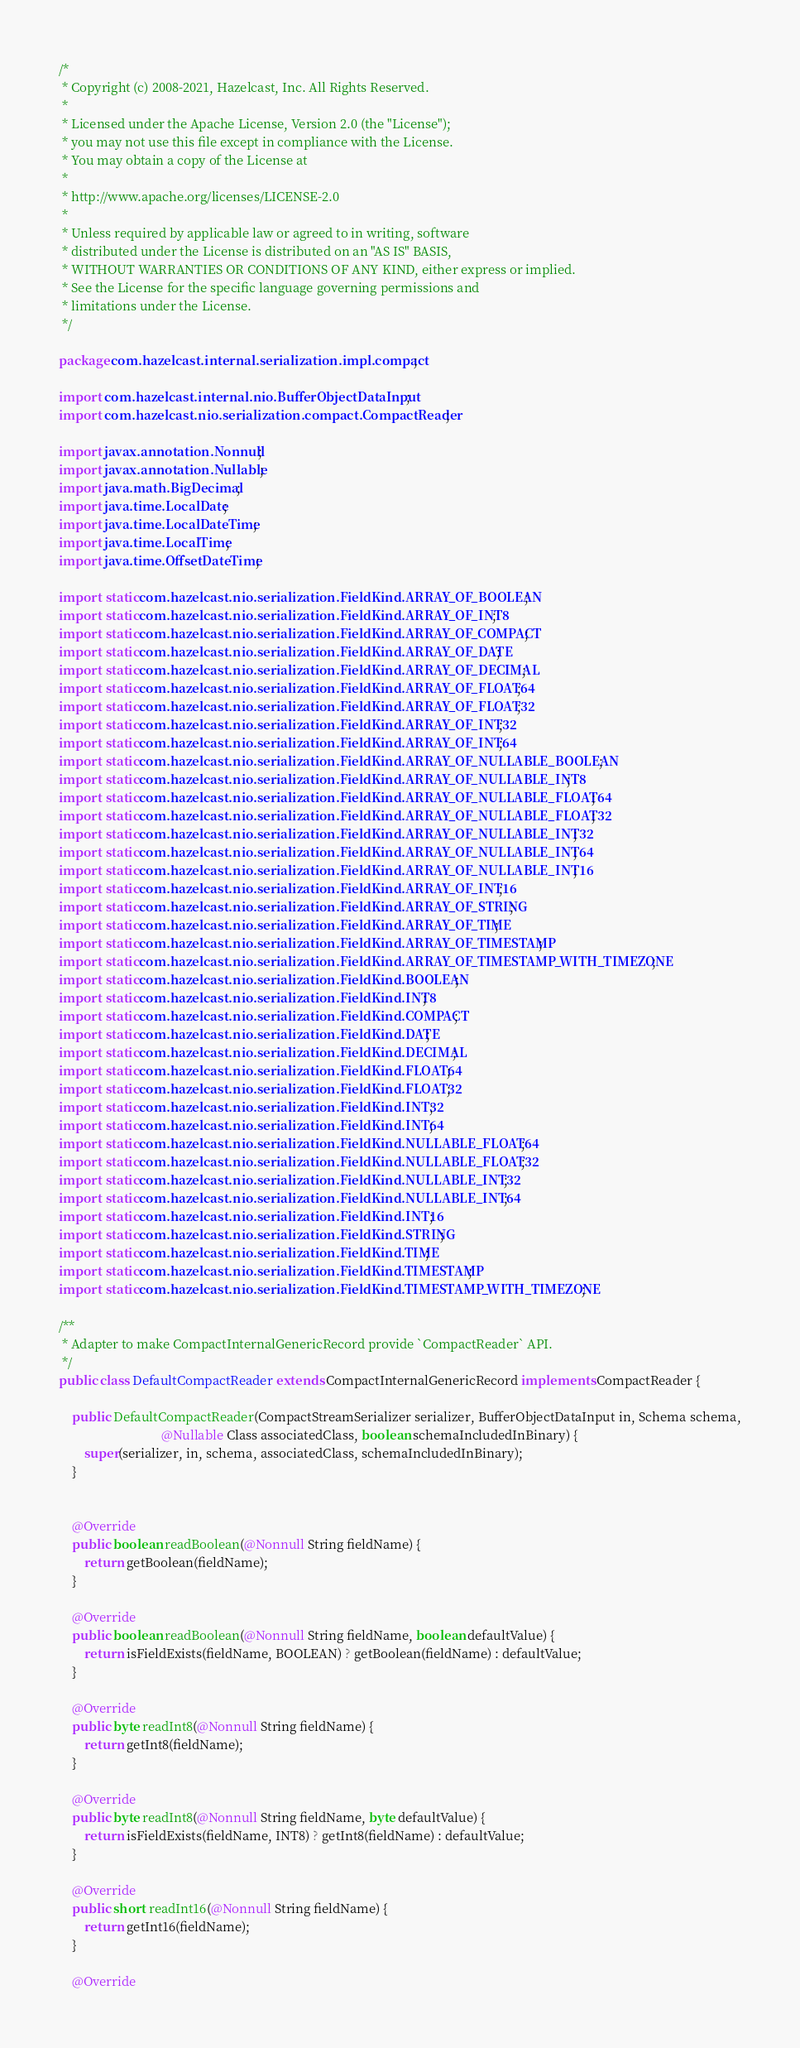<code> <loc_0><loc_0><loc_500><loc_500><_Java_>/*
 * Copyright (c) 2008-2021, Hazelcast, Inc. All Rights Reserved.
 *
 * Licensed under the Apache License, Version 2.0 (the "License");
 * you may not use this file except in compliance with the License.
 * You may obtain a copy of the License at
 *
 * http://www.apache.org/licenses/LICENSE-2.0
 *
 * Unless required by applicable law or agreed to in writing, software
 * distributed under the License is distributed on an "AS IS" BASIS,
 * WITHOUT WARRANTIES OR CONDITIONS OF ANY KIND, either express or implied.
 * See the License for the specific language governing permissions and
 * limitations under the License.
 */

package com.hazelcast.internal.serialization.impl.compact;

import com.hazelcast.internal.nio.BufferObjectDataInput;
import com.hazelcast.nio.serialization.compact.CompactReader;

import javax.annotation.Nonnull;
import javax.annotation.Nullable;
import java.math.BigDecimal;
import java.time.LocalDate;
import java.time.LocalDateTime;
import java.time.LocalTime;
import java.time.OffsetDateTime;

import static com.hazelcast.nio.serialization.FieldKind.ARRAY_OF_BOOLEAN;
import static com.hazelcast.nio.serialization.FieldKind.ARRAY_OF_INT8;
import static com.hazelcast.nio.serialization.FieldKind.ARRAY_OF_COMPACT;
import static com.hazelcast.nio.serialization.FieldKind.ARRAY_OF_DATE;
import static com.hazelcast.nio.serialization.FieldKind.ARRAY_OF_DECIMAL;
import static com.hazelcast.nio.serialization.FieldKind.ARRAY_OF_FLOAT64;
import static com.hazelcast.nio.serialization.FieldKind.ARRAY_OF_FLOAT32;
import static com.hazelcast.nio.serialization.FieldKind.ARRAY_OF_INT32;
import static com.hazelcast.nio.serialization.FieldKind.ARRAY_OF_INT64;
import static com.hazelcast.nio.serialization.FieldKind.ARRAY_OF_NULLABLE_BOOLEAN;
import static com.hazelcast.nio.serialization.FieldKind.ARRAY_OF_NULLABLE_INT8;
import static com.hazelcast.nio.serialization.FieldKind.ARRAY_OF_NULLABLE_FLOAT64;
import static com.hazelcast.nio.serialization.FieldKind.ARRAY_OF_NULLABLE_FLOAT32;
import static com.hazelcast.nio.serialization.FieldKind.ARRAY_OF_NULLABLE_INT32;
import static com.hazelcast.nio.serialization.FieldKind.ARRAY_OF_NULLABLE_INT64;
import static com.hazelcast.nio.serialization.FieldKind.ARRAY_OF_NULLABLE_INT16;
import static com.hazelcast.nio.serialization.FieldKind.ARRAY_OF_INT16;
import static com.hazelcast.nio.serialization.FieldKind.ARRAY_OF_STRING;
import static com.hazelcast.nio.serialization.FieldKind.ARRAY_OF_TIME;
import static com.hazelcast.nio.serialization.FieldKind.ARRAY_OF_TIMESTAMP;
import static com.hazelcast.nio.serialization.FieldKind.ARRAY_OF_TIMESTAMP_WITH_TIMEZONE;
import static com.hazelcast.nio.serialization.FieldKind.BOOLEAN;
import static com.hazelcast.nio.serialization.FieldKind.INT8;
import static com.hazelcast.nio.serialization.FieldKind.COMPACT;
import static com.hazelcast.nio.serialization.FieldKind.DATE;
import static com.hazelcast.nio.serialization.FieldKind.DECIMAL;
import static com.hazelcast.nio.serialization.FieldKind.FLOAT64;
import static com.hazelcast.nio.serialization.FieldKind.FLOAT32;
import static com.hazelcast.nio.serialization.FieldKind.INT32;
import static com.hazelcast.nio.serialization.FieldKind.INT64;
import static com.hazelcast.nio.serialization.FieldKind.NULLABLE_FLOAT64;
import static com.hazelcast.nio.serialization.FieldKind.NULLABLE_FLOAT32;
import static com.hazelcast.nio.serialization.FieldKind.NULLABLE_INT32;
import static com.hazelcast.nio.serialization.FieldKind.NULLABLE_INT64;
import static com.hazelcast.nio.serialization.FieldKind.INT16;
import static com.hazelcast.nio.serialization.FieldKind.STRING;
import static com.hazelcast.nio.serialization.FieldKind.TIME;
import static com.hazelcast.nio.serialization.FieldKind.TIMESTAMP;
import static com.hazelcast.nio.serialization.FieldKind.TIMESTAMP_WITH_TIMEZONE;

/**
 * Adapter to make CompactInternalGenericRecord provide `CompactReader` API.
 */
public class DefaultCompactReader extends CompactInternalGenericRecord implements CompactReader {

    public DefaultCompactReader(CompactStreamSerializer serializer, BufferObjectDataInput in, Schema schema,
                                @Nullable Class associatedClass, boolean schemaIncludedInBinary) {
        super(serializer, in, schema, associatedClass, schemaIncludedInBinary);
    }


    @Override
    public boolean readBoolean(@Nonnull String fieldName) {
        return getBoolean(fieldName);
    }

    @Override
    public boolean readBoolean(@Nonnull String fieldName, boolean defaultValue) {
        return isFieldExists(fieldName, BOOLEAN) ? getBoolean(fieldName) : defaultValue;
    }

    @Override
    public byte readInt8(@Nonnull String fieldName) {
        return getInt8(fieldName);
    }

    @Override
    public byte readInt8(@Nonnull String fieldName, byte defaultValue) {
        return isFieldExists(fieldName, INT8) ? getInt8(fieldName) : defaultValue;
    }

    @Override
    public short readInt16(@Nonnull String fieldName) {
        return getInt16(fieldName);
    }

    @Override</code> 